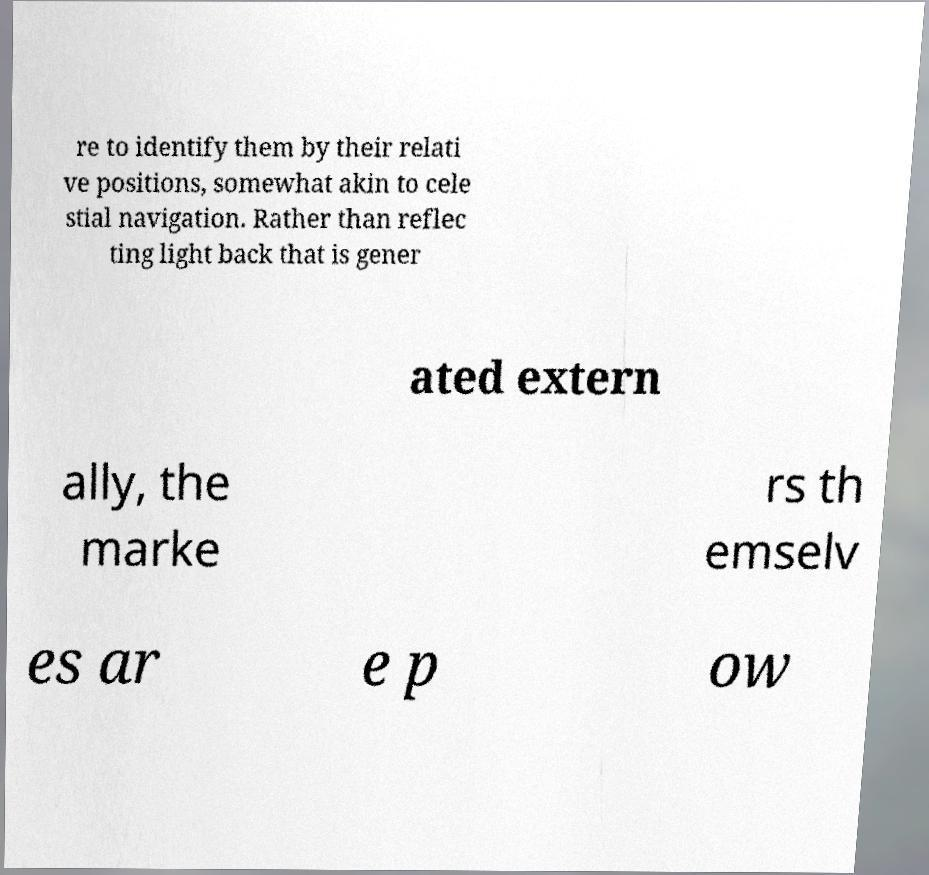Can you read and provide the text displayed in the image?This photo seems to have some interesting text. Can you extract and type it out for me? re to identify them by their relati ve positions, somewhat akin to cele stial navigation. Rather than reflec ting light back that is gener ated extern ally, the marke rs th emselv es ar e p ow 